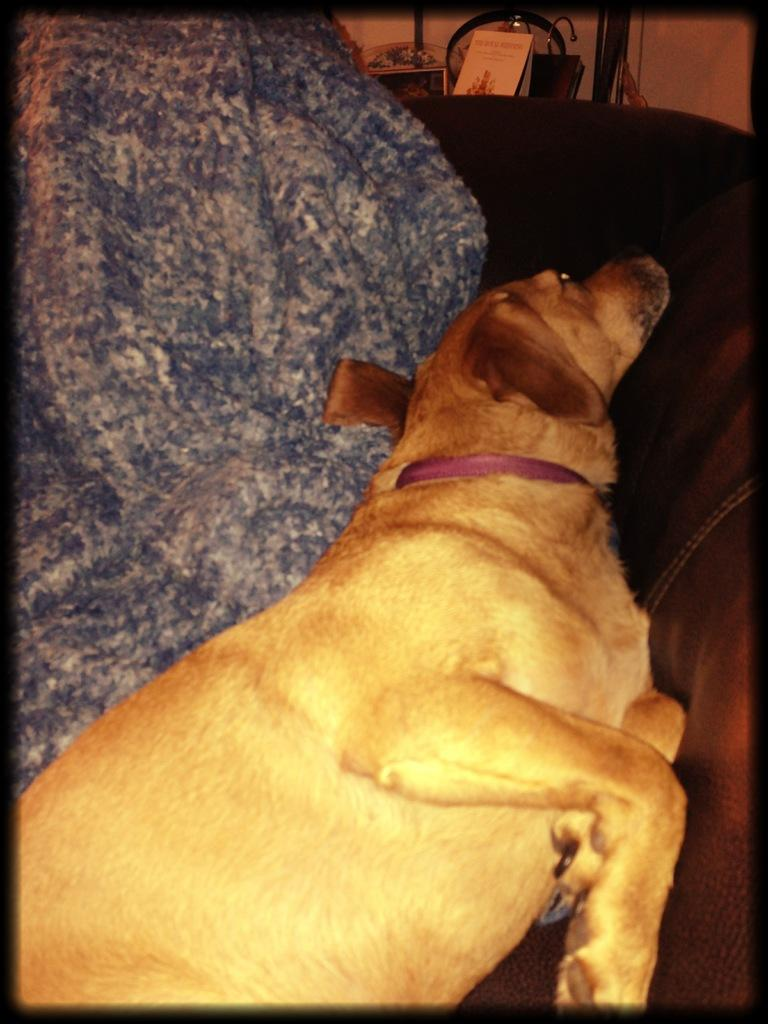What type of animal is in the image? There is a dog in the image. What accessory can be seen in the image? There is a belt in the image. What can be seen in the background of the image? There are objects in the background of the image. What is the purpose of the throne in the image? There is no throne present in the image. 